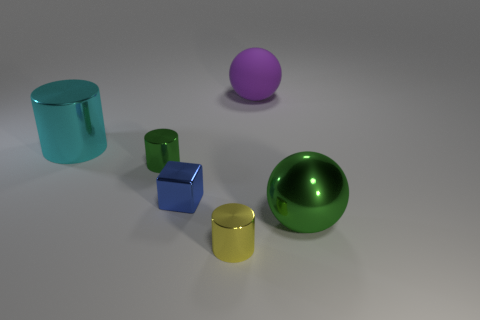There is a metal object that is the same color as the metal ball; what is its size?
Your answer should be compact. Small. What size is the blue cube that is the same material as the tiny green cylinder?
Offer a very short reply. Small. There is a big metallic object behind the small object that is behind the cube; what is its shape?
Give a very brief answer. Cylinder. What number of blue objects are either small balls or big metal things?
Your answer should be very brief. 0. Are there any green spheres that are to the left of the tiny shiny object that is in front of the large ball that is in front of the cyan metal cylinder?
Your answer should be very brief. No. What shape is the small thing that is the same color as the large shiny sphere?
Make the answer very short. Cylinder. Is there anything else that is the same material as the big cyan thing?
Give a very brief answer. Yes. What number of small objects are either green metal objects or rubber balls?
Your response must be concise. 1. There is a green metal thing on the right side of the big purple ball; is it the same shape as the purple thing?
Your answer should be compact. Yes. Are there fewer large purple balls than metallic cylinders?
Your response must be concise. Yes. 